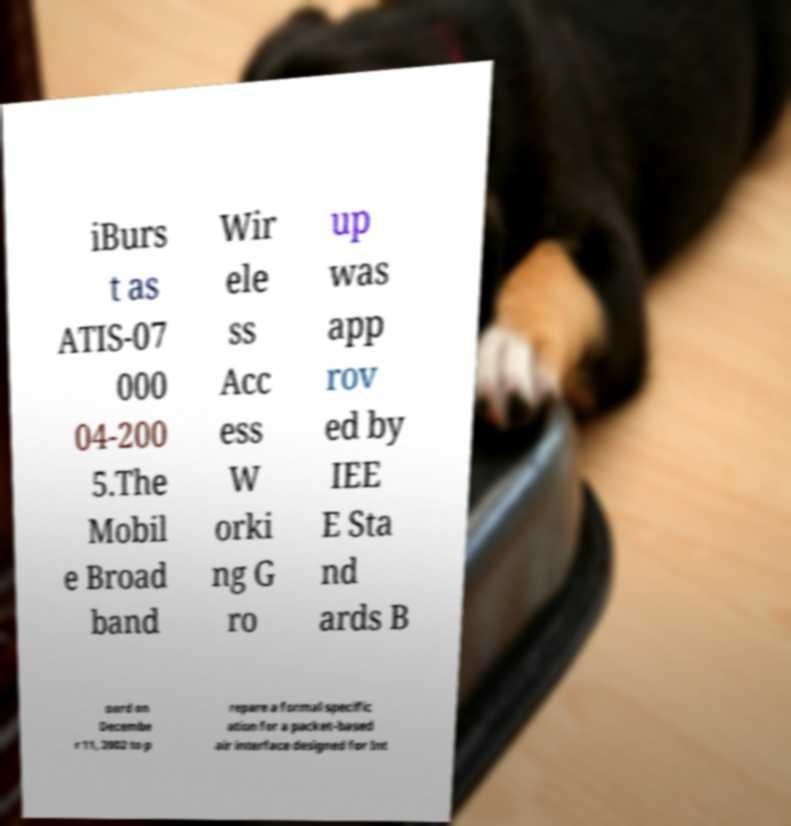What messages or text are displayed in this image? I need them in a readable, typed format. iBurs t as ATIS-07 000 04-200 5.The Mobil e Broad band Wir ele ss Acc ess W orki ng G ro up was app rov ed by IEE E Sta nd ards B oard on Decembe r 11, 2002 to p repare a formal specific ation for a packet-based air interface designed for Int 